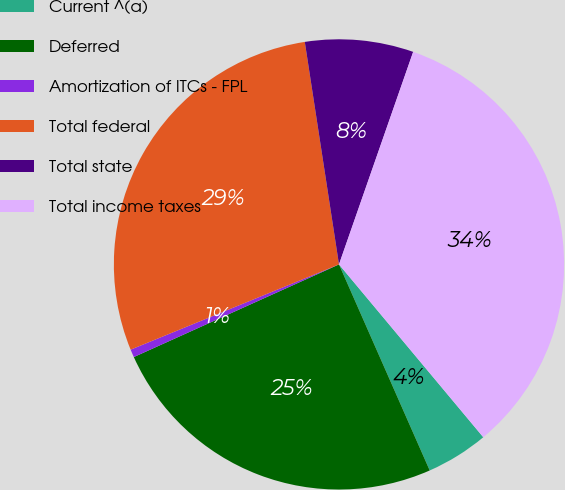Convert chart to OTSL. <chart><loc_0><loc_0><loc_500><loc_500><pie_chart><fcel>Current ^(a)<fcel>Deferred<fcel>Amortization of ITCs - FPL<fcel>Total federal<fcel>Total state<fcel>Total income taxes<nl><fcel>4.47%<fcel>24.85%<fcel>0.57%<fcel>28.75%<fcel>7.77%<fcel>33.58%<nl></chart> 